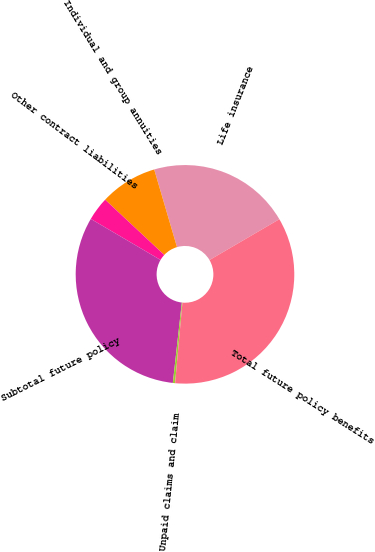Convert chart to OTSL. <chart><loc_0><loc_0><loc_500><loc_500><pie_chart><fcel>Life insurance<fcel>Individual and group annuities<fcel>Other contract liabilities<fcel>Subtotal future policy<fcel>Unpaid claims and claim<fcel>Total future policy benefits<nl><fcel>21.13%<fcel>8.49%<fcel>3.5%<fcel>31.69%<fcel>0.33%<fcel>34.86%<nl></chart> 